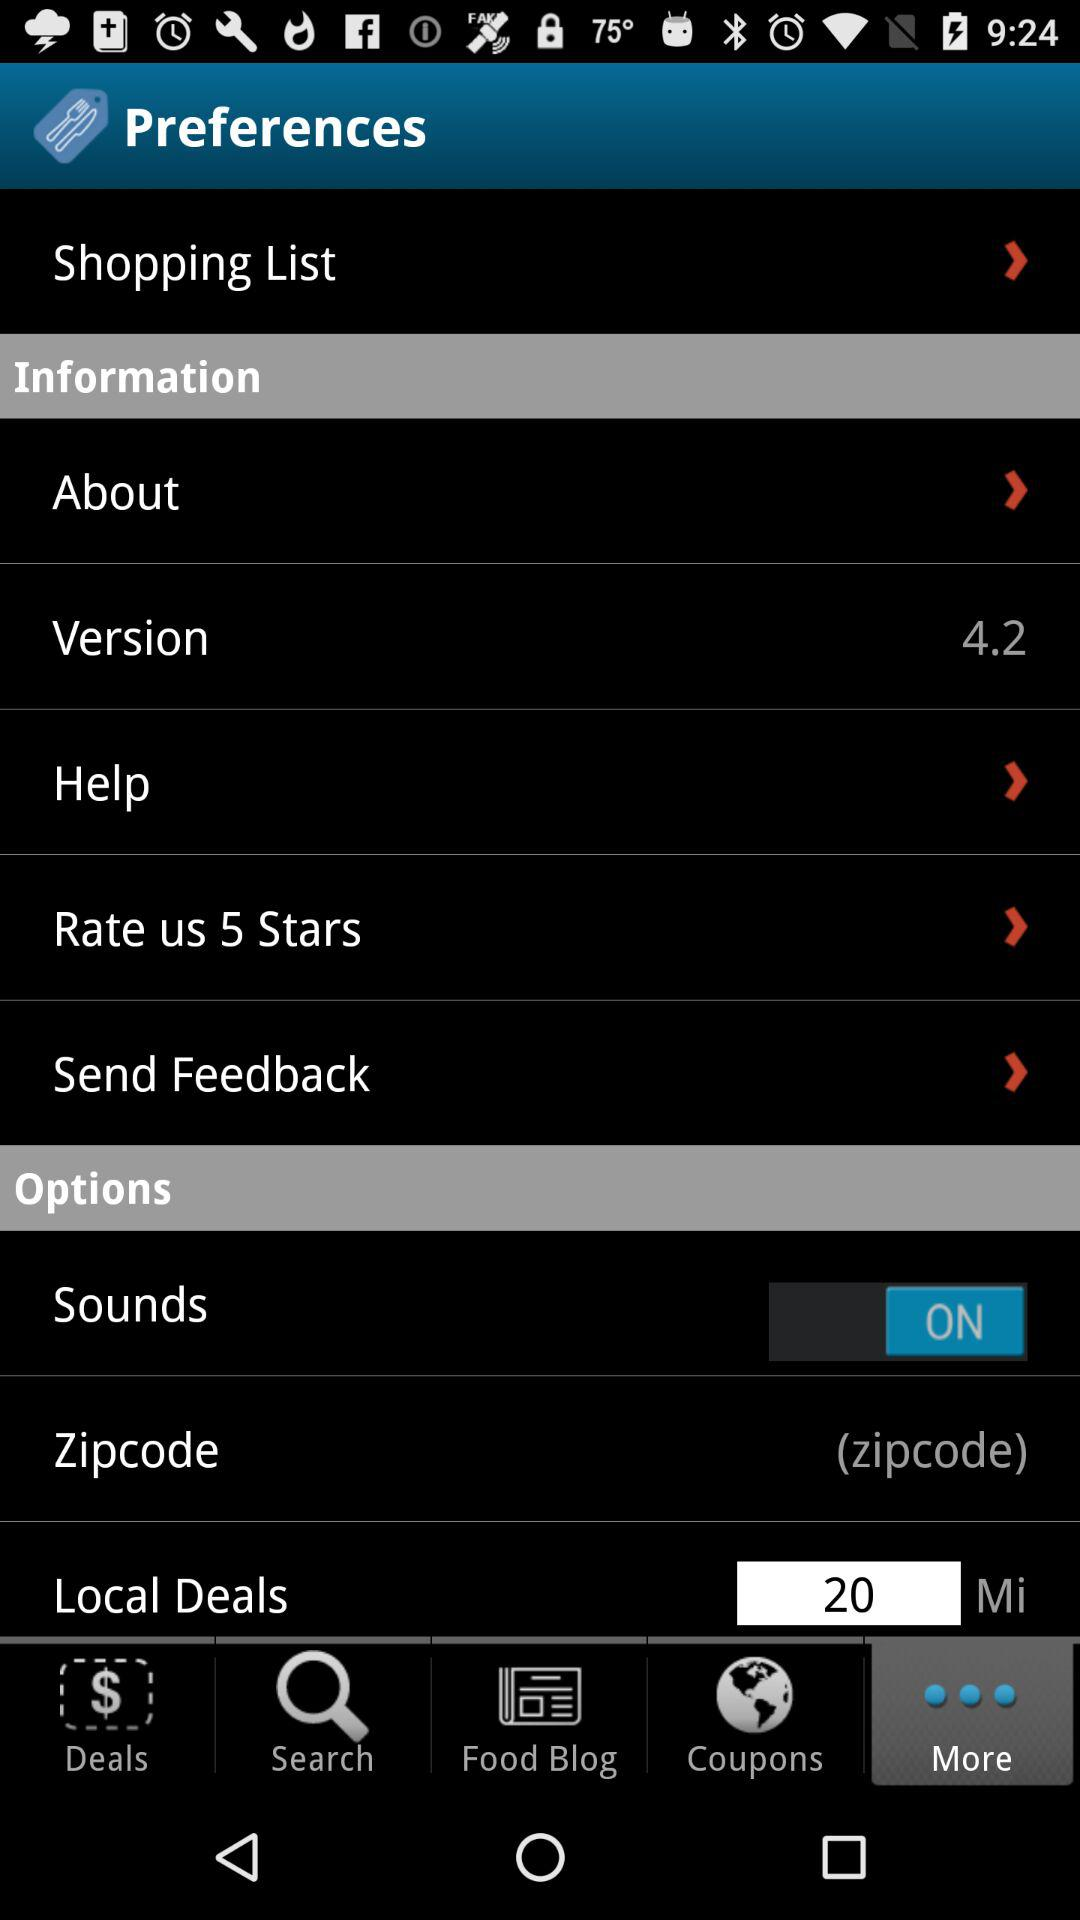What is the status of sounds? The status of sounds is on. 